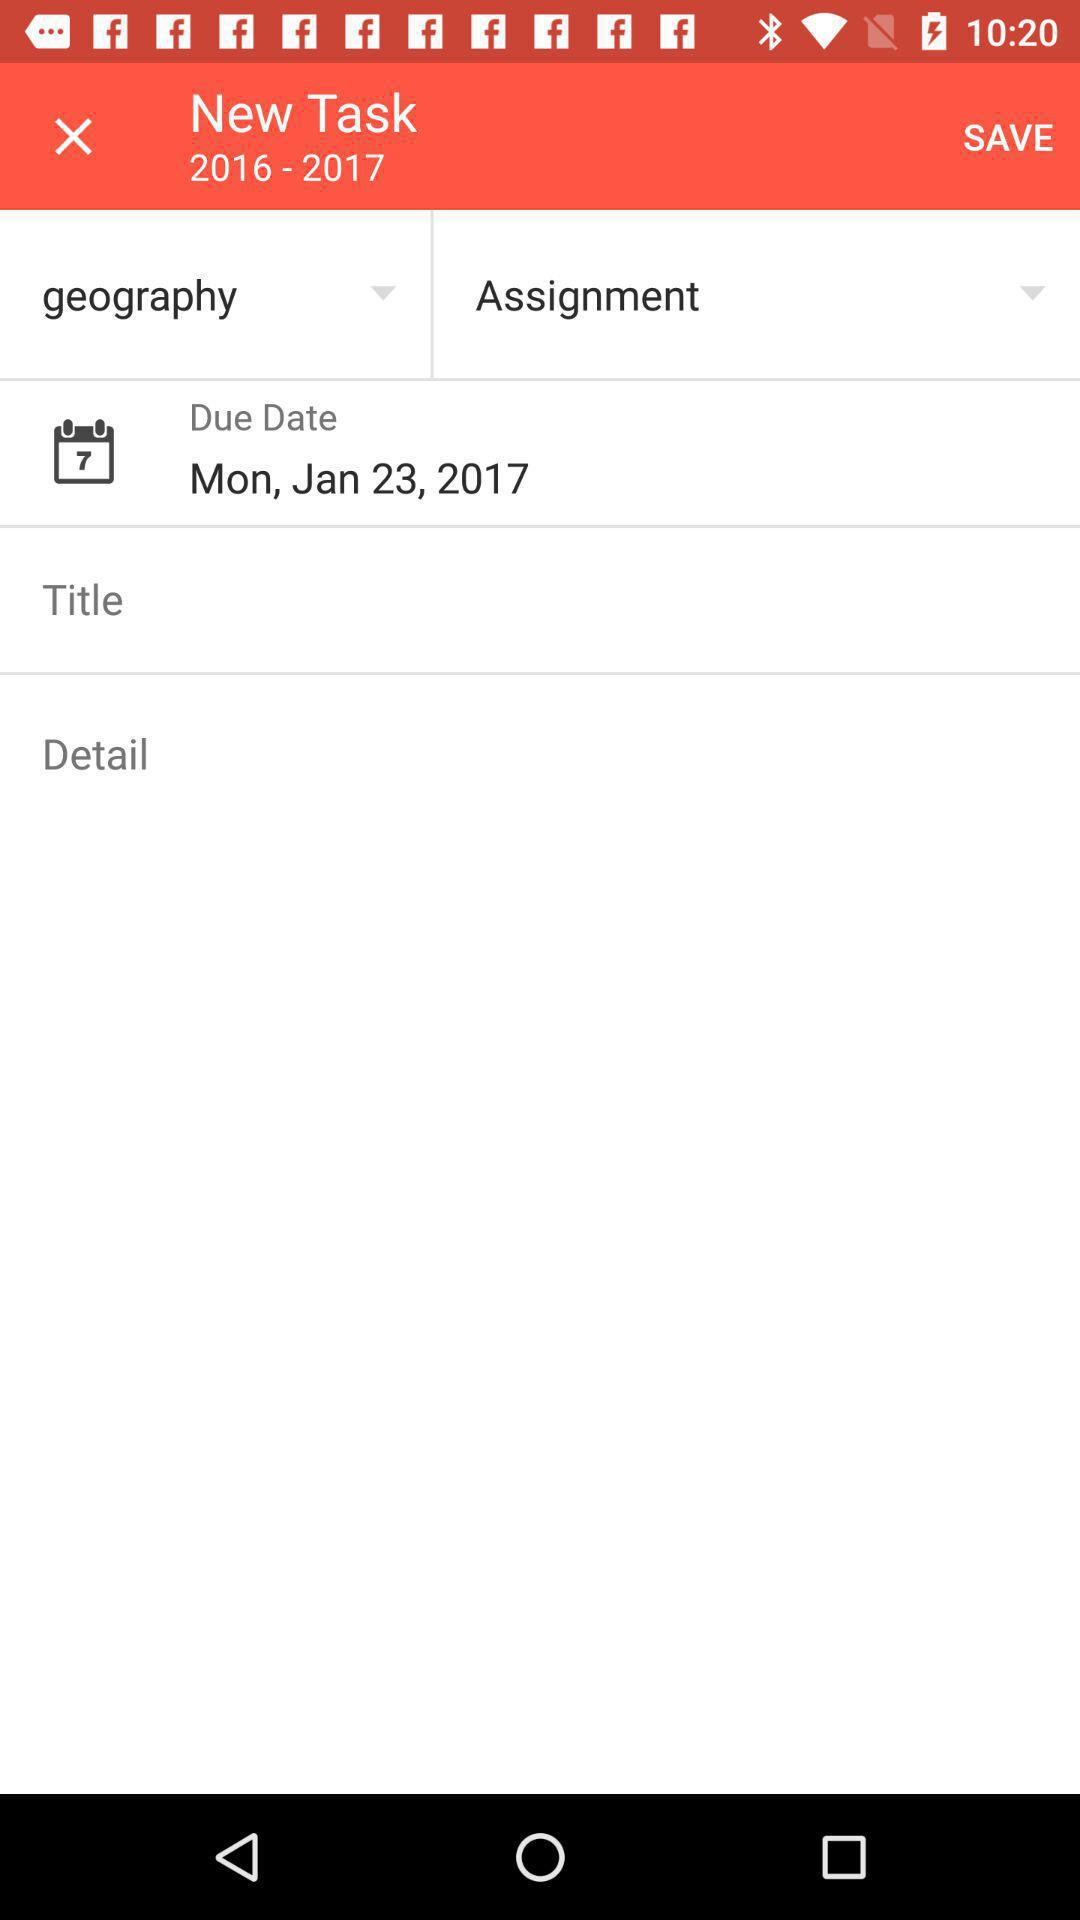What is the due date? The due date is Monday, January 23, 2017. 